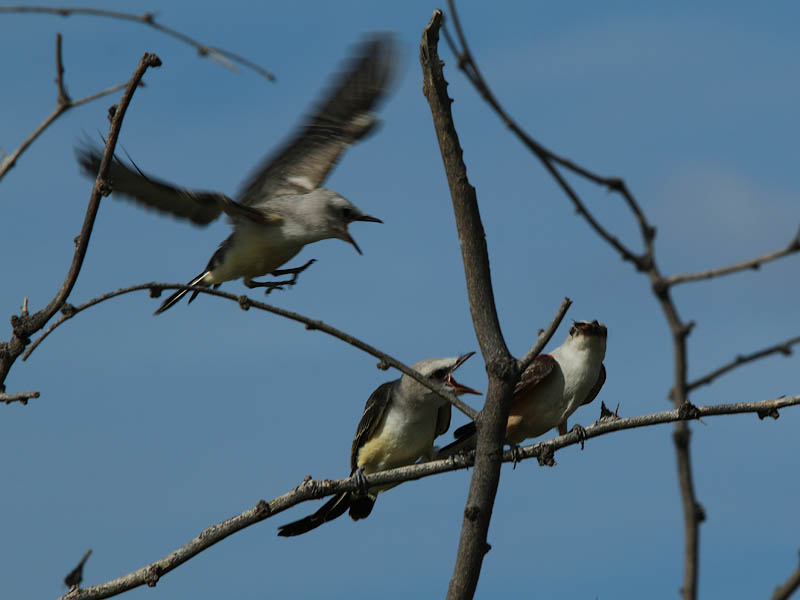Considering the open beak of the front perched bird and the presence of the other birds, what might be the reason for this behavior and how does it relate to the actions of the other two birds? The image captures a moment rich with avian activity. The perched bird with its beak open skyward is exhibiting a behavior typical of young birds signaling hunger and readiness to receive food, likely anticipating a feeding from a parent or a sibling. The open beak is a visual cue for the adult birds, indicating that it is time to provide nourishment. The action of the bird in flight suggests dynamic movement within this familial bond, either illustrating the approach of a parent returning with a meal or depicting a fledgling practicing its flight skills, which is part of its natural development. Meanwhile, the bird sitting adjacent to the one with the open beak, facing in the same direction, could represent a sibling awaiting its turn, exemplifying the cooperative and sometimes competitive nature of sibling birds. 